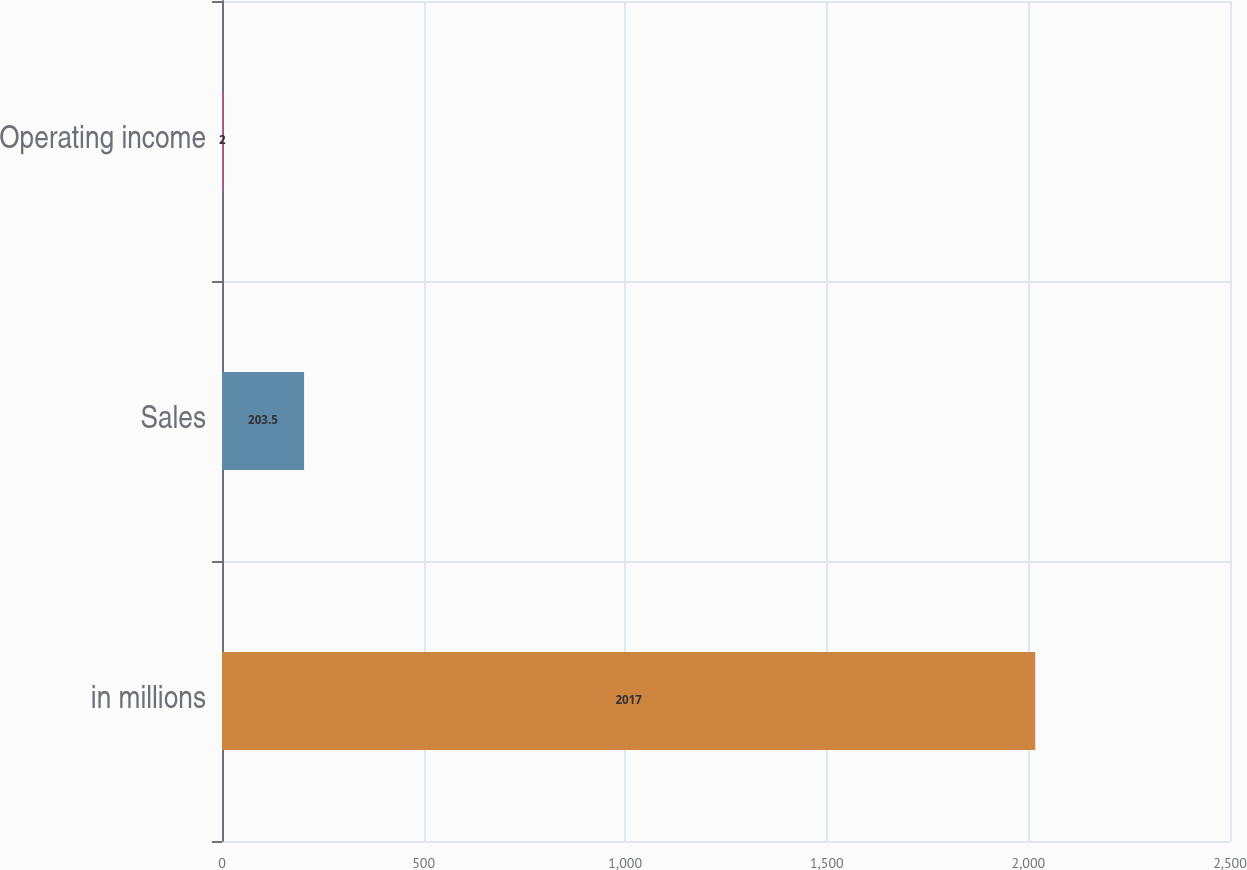<chart> <loc_0><loc_0><loc_500><loc_500><bar_chart><fcel>in millions<fcel>Sales<fcel>Operating income<nl><fcel>2017<fcel>203.5<fcel>2<nl></chart> 